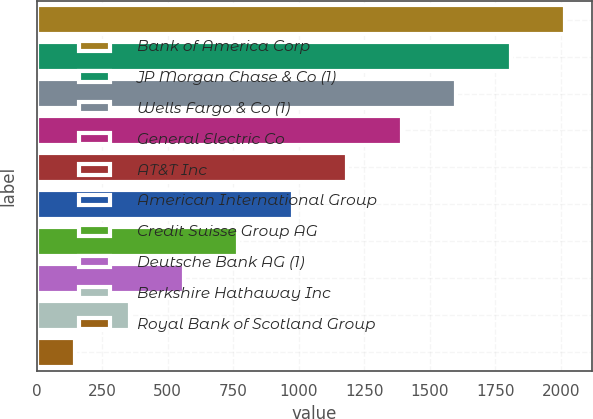Convert chart. <chart><loc_0><loc_0><loc_500><loc_500><bar_chart><fcel>Bank of America Corp<fcel>JP Morgan Chase & Co (1)<fcel>Wells Fargo & Co (1)<fcel>General Electric Co<fcel>AT&T Inc<fcel>American International Group<fcel>Credit Suisse Group AG<fcel>Deutsche Bank AG (1)<fcel>Berkshire Hathaway Inc<fcel>Royal Bank of Scotland Group<nl><fcel>2016.64<fcel>1808.88<fcel>1601.12<fcel>1393.36<fcel>1185.6<fcel>977.84<fcel>770.08<fcel>562.32<fcel>354.56<fcel>146.8<nl></chart> 